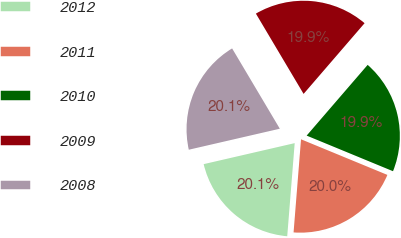<chart> <loc_0><loc_0><loc_500><loc_500><pie_chart><fcel>2012<fcel>2011<fcel>2010<fcel>2009<fcel>2008<nl><fcel>20.12%<fcel>20.05%<fcel>19.9%<fcel>19.86%<fcel>20.08%<nl></chart> 